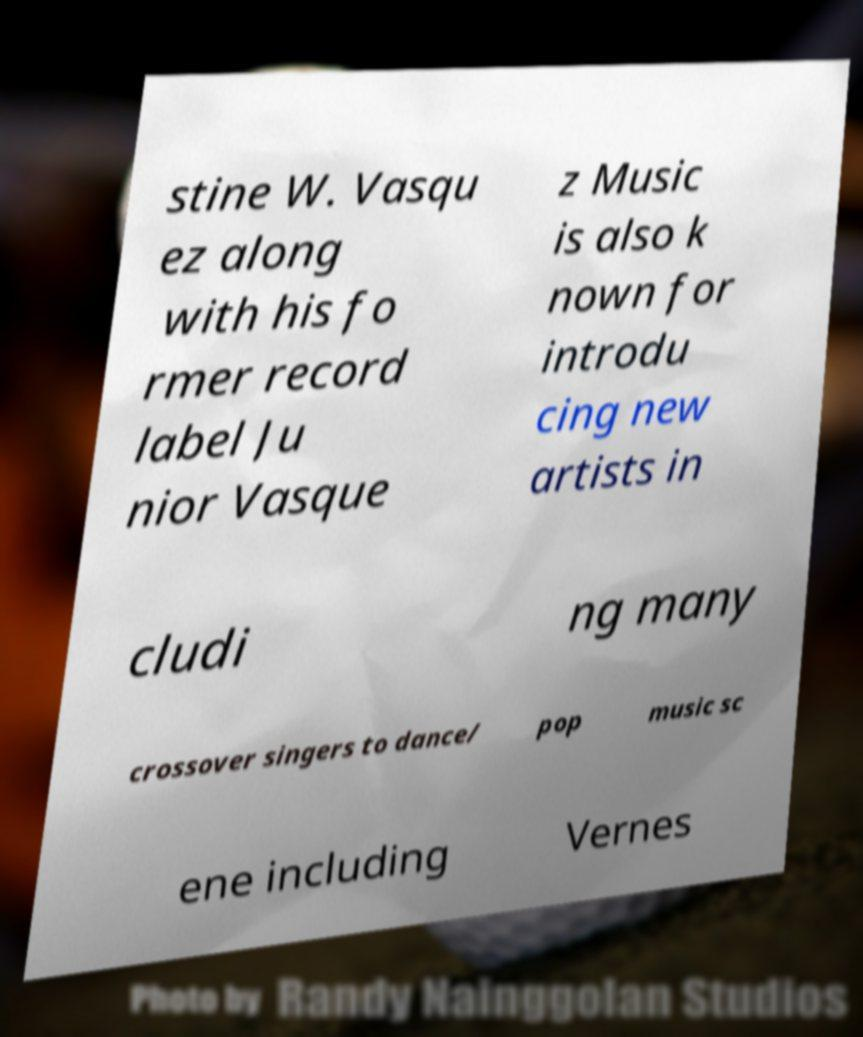Please identify and transcribe the text found in this image. stine W. Vasqu ez along with his fo rmer record label Ju nior Vasque z Music is also k nown for introdu cing new artists in cludi ng many crossover singers to dance/ pop music sc ene including Vernes 